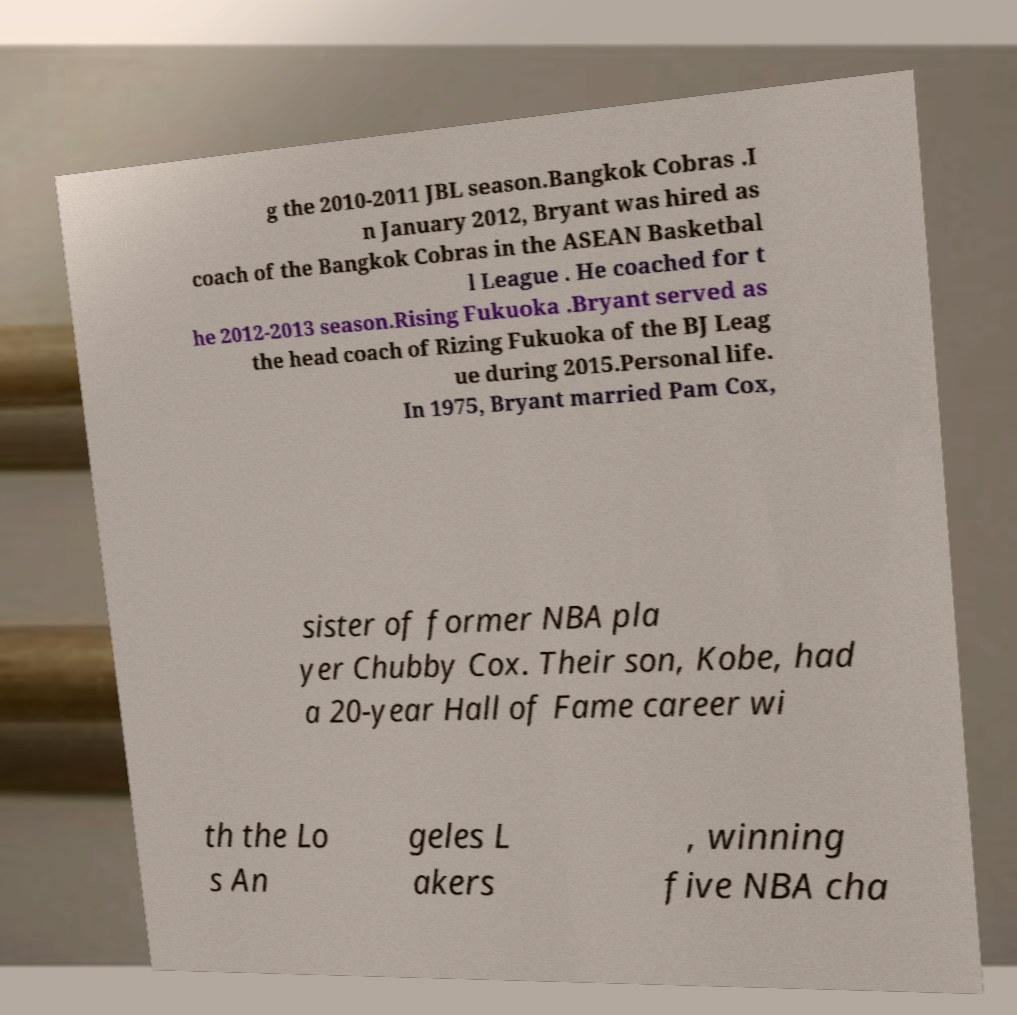I need the written content from this picture converted into text. Can you do that? g the 2010-2011 JBL season.Bangkok Cobras .I n January 2012, Bryant was hired as coach of the Bangkok Cobras in the ASEAN Basketbal l League . He coached for t he 2012-2013 season.Rising Fukuoka .Bryant served as the head coach of Rizing Fukuoka of the BJ Leag ue during 2015.Personal life. In 1975, Bryant married Pam Cox, sister of former NBA pla yer Chubby Cox. Their son, Kobe, had a 20-year Hall of Fame career wi th the Lo s An geles L akers , winning five NBA cha 